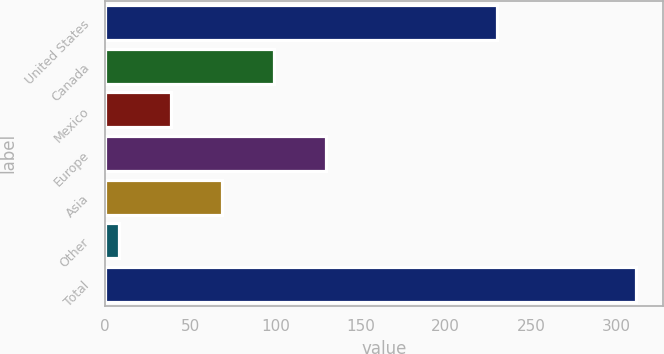Convert chart. <chart><loc_0><loc_0><loc_500><loc_500><bar_chart><fcel>United States<fcel>Canada<fcel>Mexico<fcel>Europe<fcel>Asia<fcel>Other<fcel>Total<nl><fcel>230<fcel>99.2<fcel>38.4<fcel>129.6<fcel>68.8<fcel>8<fcel>312<nl></chart> 